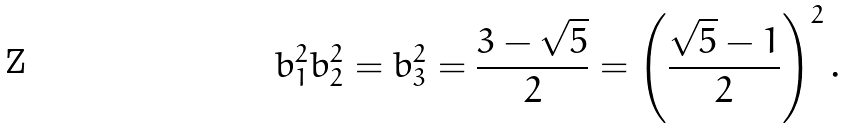Convert formula to latex. <formula><loc_0><loc_0><loc_500><loc_500>b _ { 1 } ^ { 2 } b _ { 2 } ^ { 2 } = b _ { 3 } ^ { 2 } = \frac { 3 - \sqrt { 5 } } { 2 } = \left ( \frac { \sqrt { 5 } - 1 } { 2 } \right ) ^ { 2 } .</formula> 